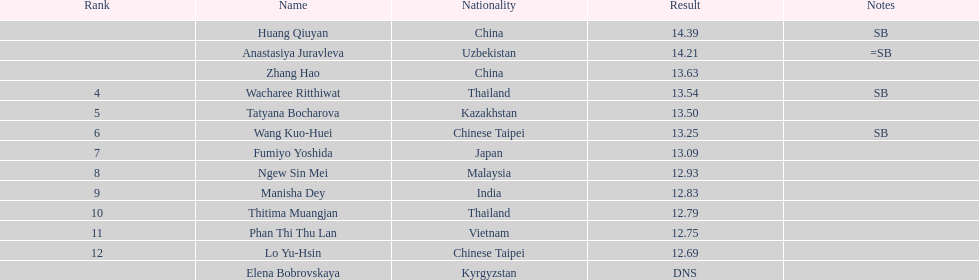What was the median performance of the top three jumpers? 14.08. 